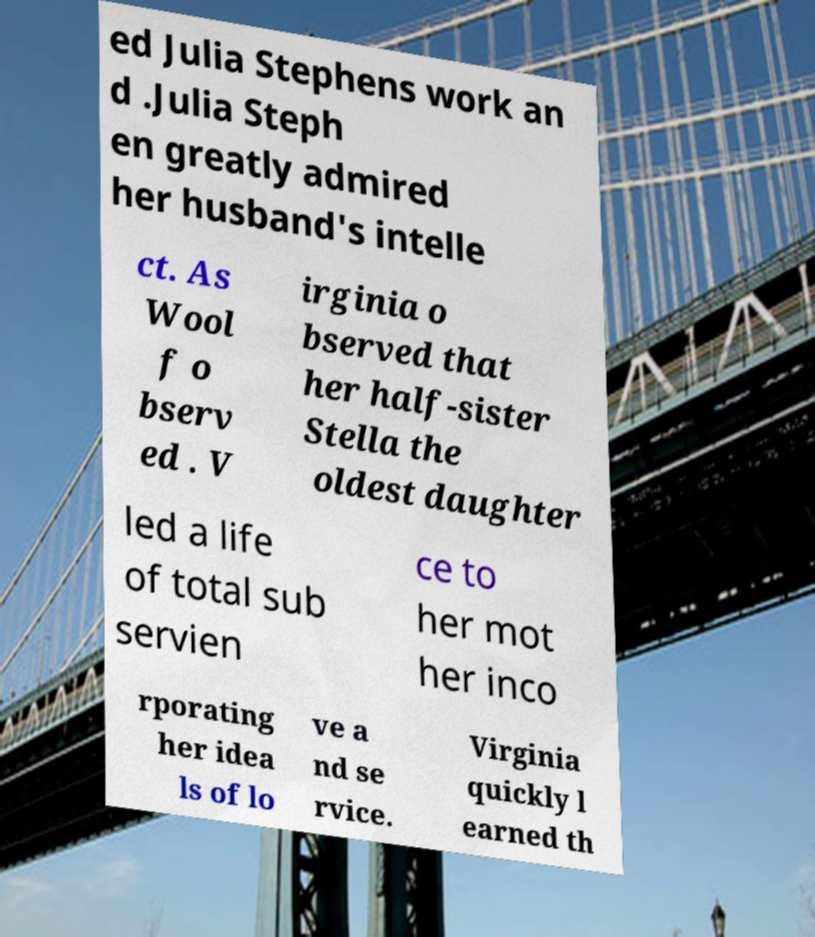For documentation purposes, I need the text within this image transcribed. Could you provide that? ed Julia Stephens work an d .Julia Steph en greatly admired her husband's intelle ct. As Wool f o bserv ed . V irginia o bserved that her half-sister Stella the oldest daughter led a life of total sub servien ce to her mot her inco rporating her idea ls of lo ve a nd se rvice. Virginia quickly l earned th 